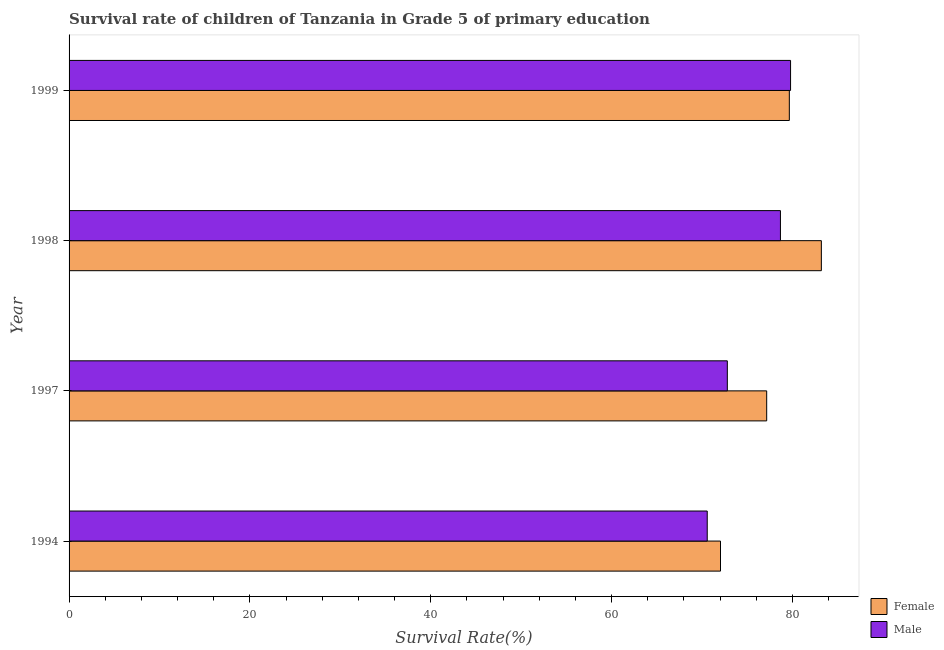How many different coloured bars are there?
Provide a short and direct response. 2. How many groups of bars are there?
Your answer should be compact. 4. Are the number of bars per tick equal to the number of legend labels?
Keep it short and to the point. Yes. How many bars are there on the 1st tick from the top?
Your answer should be very brief. 2. What is the label of the 4th group of bars from the top?
Your answer should be very brief. 1994. In how many cases, is the number of bars for a given year not equal to the number of legend labels?
Your answer should be compact. 0. What is the survival rate of male students in primary education in 1997?
Give a very brief answer. 72.79. Across all years, what is the maximum survival rate of female students in primary education?
Offer a terse response. 83.19. Across all years, what is the minimum survival rate of female students in primary education?
Provide a short and direct response. 72.04. In which year was the survival rate of male students in primary education minimum?
Your response must be concise. 1994. What is the total survival rate of female students in primary education in the graph?
Offer a very short reply. 312.03. What is the difference between the survival rate of male students in primary education in 1997 and that in 1999?
Your answer should be very brief. -6.99. What is the difference between the survival rate of female students in primary education in 1998 and the survival rate of male students in primary education in 1997?
Provide a short and direct response. 10.4. What is the average survival rate of female students in primary education per year?
Offer a terse response. 78.01. In the year 1998, what is the difference between the survival rate of male students in primary education and survival rate of female students in primary education?
Offer a very short reply. -4.53. In how many years, is the survival rate of female students in primary education greater than 76 %?
Ensure brevity in your answer.  3. What is the ratio of the survival rate of male students in primary education in 1994 to that in 1999?
Make the answer very short. 0.89. What is the difference between the highest and the second highest survival rate of female students in primary education?
Your answer should be very brief. 3.54. What is the difference between the highest and the lowest survival rate of male students in primary education?
Ensure brevity in your answer.  9.21. What does the 2nd bar from the bottom in 1999 represents?
Offer a terse response. Male. Does the graph contain grids?
Offer a terse response. No. Where does the legend appear in the graph?
Make the answer very short. Bottom right. How many legend labels are there?
Provide a short and direct response. 2. What is the title of the graph?
Give a very brief answer. Survival rate of children of Tanzania in Grade 5 of primary education. Does "Secondary Education" appear as one of the legend labels in the graph?
Your answer should be compact. No. What is the label or title of the X-axis?
Provide a succinct answer. Survival Rate(%). What is the Survival Rate(%) of Female in 1994?
Offer a very short reply. 72.04. What is the Survival Rate(%) of Male in 1994?
Make the answer very short. 70.57. What is the Survival Rate(%) in Female in 1997?
Your answer should be compact. 77.15. What is the Survival Rate(%) in Male in 1997?
Offer a very short reply. 72.79. What is the Survival Rate(%) of Female in 1998?
Your answer should be compact. 83.19. What is the Survival Rate(%) in Male in 1998?
Give a very brief answer. 78.67. What is the Survival Rate(%) in Female in 1999?
Provide a short and direct response. 79.65. What is the Survival Rate(%) of Male in 1999?
Keep it short and to the point. 79.79. Across all years, what is the maximum Survival Rate(%) in Female?
Make the answer very short. 83.19. Across all years, what is the maximum Survival Rate(%) of Male?
Your answer should be very brief. 79.79. Across all years, what is the minimum Survival Rate(%) in Female?
Provide a short and direct response. 72.04. Across all years, what is the minimum Survival Rate(%) in Male?
Make the answer very short. 70.57. What is the total Survival Rate(%) in Female in the graph?
Your response must be concise. 312.03. What is the total Survival Rate(%) in Male in the graph?
Offer a very short reply. 301.82. What is the difference between the Survival Rate(%) in Female in 1994 and that in 1997?
Make the answer very short. -5.11. What is the difference between the Survival Rate(%) in Male in 1994 and that in 1997?
Your answer should be very brief. -2.22. What is the difference between the Survival Rate(%) in Female in 1994 and that in 1998?
Your response must be concise. -11.15. What is the difference between the Survival Rate(%) of Male in 1994 and that in 1998?
Make the answer very short. -8.1. What is the difference between the Survival Rate(%) of Female in 1994 and that in 1999?
Your answer should be very brief. -7.61. What is the difference between the Survival Rate(%) of Male in 1994 and that in 1999?
Provide a short and direct response. -9.21. What is the difference between the Survival Rate(%) of Female in 1997 and that in 1998?
Provide a succinct answer. -6.05. What is the difference between the Survival Rate(%) of Male in 1997 and that in 1998?
Offer a very short reply. -5.87. What is the difference between the Survival Rate(%) of Female in 1997 and that in 1999?
Your answer should be compact. -2.5. What is the difference between the Survival Rate(%) of Male in 1997 and that in 1999?
Provide a short and direct response. -6.99. What is the difference between the Survival Rate(%) of Female in 1998 and that in 1999?
Your answer should be very brief. 3.54. What is the difference between the Survival Rate(%) in Male in 1998 and that in 1999?
Provide a succinct answer. -1.12. What is the difference between the Survival Rate(%) in Female in 1994 and the Survival Rate(%) in Male in 1997?
Provide a succinct answer. -0.76. What is the difference between the Survival Rate(%) in Female in 1994 and the Survival Rate(%) in Male in 1998?
Keep it short and to the point. -6.63. What is the difference between the Survival Rate(%) of Female in 1994 and the Survival Rate(%) of Male in 1999?
Provide a short and direct response. -7.75. What is the difference between the Survival Rate(%) in Female in 1997 and the Survival Rate(%) in Male in 1998?
Offer a terse response. -1.52. What is the difference between the Survival Rate(%) in Female in 1997 and the Survival Rate(%) in Male in 1999?
Keep it short and to the point. -2.64. What is the difference between the Survival Rate(%) in Female in 1998 and the Survival Rate(%) in Male in 1999?
Offer a very short reply. 3.41. What is the average Survival Rate(%) of Female per year?
Offer a terse response. 78.01. What is the average Survival Rate(%) in Male per year?
Your response must be concise. 75.46. In the year 1994, what is the difference between the Survival Rate(%) of Female and Survival Rate(%) of Male?
Make the answer very short. 1.47. In the year 1997, what is the difference between the Survival Rate(%) in Female and Survival Rate(%) in Male?
Keep it short and to the point. 4.35. In the year 1998, what is the difference between the Survival Rate(%) of Female and Survival Rate(%) of Male?
Provide a short and direct response. 4.53. In the year 1999, what is the difference between the Survival Rate(%) of Female and Survival Rate(%) of Male?
Offer a terse response. -0.14. What is the ratio of the Survival Rate(%) of Female in 1994 to that in 1997?
Your answer should be compact. 0.93. What is the ratio of the Survival Rate(%) of Male in 1994 to that in 1997?
Give a very brief answer. 0.97. What is the ratio of the Survival Rate(%) in Female in 1994 to that in 1998?
Make the answer very short. 0.87. What is the ratio of the Survival Rate(%) in Male in 1994 to that in 1998?
Offer a very short reply. 0.9. What is the ratio of the Survival Rate(%) of Female in 1994 to that in 1999?
Provide a short and direct response. 0.9. What is the ratio of the Survival Rate(%) in Male in 1994 to that in 1999?
Provide a short and direct response. 0.88. What is the ratio of the Survival Rate(%) of Female in 1997 to that in 1998?
Offer a very short reply. 0.93. What is the ratio of the Survival Rate(%) in Male in 1997 to that in 1998?
Your response must be concise. 0.93. What is the ratio of the Survival Rate(%) in Female in 1997 to that in 1999?
Your response must be concise. 0.97. What is the ratio of the Survival Rate(%) in Male in 1997 to that in 1999?
Ensure brevity in your answer.  0.91. What is the ratio of the Survival Rate(%) in Female in 1998 to that in 1999?
Your response must be concise. 1.04. What is the difference between the highest and the second highest Survival Rate(%) in Female?
Provide a succinct answer. 3.54. What is the difference between the highest and the second highest Survival Rate(%) of Male?
Make the answer very short. 1.12. What is the difference between the highest and the lowest Survival Rate(%) of Female?
Make the answer very short. 11.15. What is the difference between the highest and the lowest Survival Rate(%) in Male?
Your answer should be compact. 9.21. 